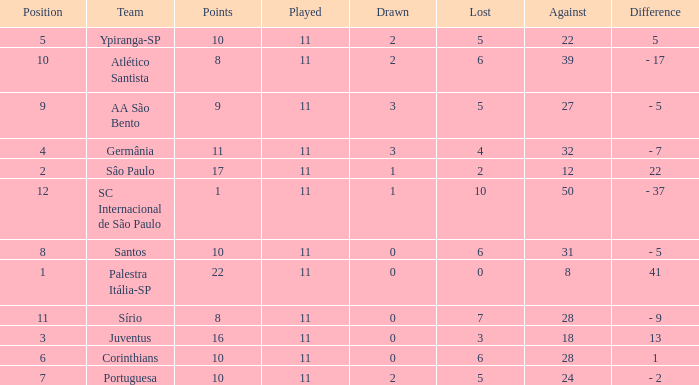Parse the full table. {'header': ['Position', 'Team', 'Points', 'Played', 'Drawn', 'Lost', 'Against', 'Difference'], 'rows': [['5', 'Ypiranga-SP', '10', '11', '2', '5', '22', '5'], ['10', 'Atlético Santista', '8', '11', '2', '6', '39', '- 17'], ['9', 'AA São Bento', '9', '11', '3', '5', '27', '- 5'], ['4', 'Germânia', '11', '11', '3', '4', '32', '- 7'], ['2', 'Sâo Paulo', '17', '11', '1', '2', '12', '22'], ['12', 'SC Internacional de São Paulo', '1', '11', '1', '10', '50', '- 37'], ['8', 'Santos', '10', '11', '0', '6', '31', '- 5'], ['1', 'Palestra Itália-SP', '22', '11', '0', '0', '8', '41'], ['11', 'Sírio', '8', '11', '0', '7', '28', '- 9'], ['3', 'Juventus', '16', '11', '0', '3', '18', '13'], ['6', 'Corinthians', '10', '11', '0', '6', '28', '1'], ['7', 'Portuguesa', '10', '11', '2', '5', '24', '- 2']]} What was the total number of Points when the value Difference was 13, and when the value Lost was greater than 3? None. 